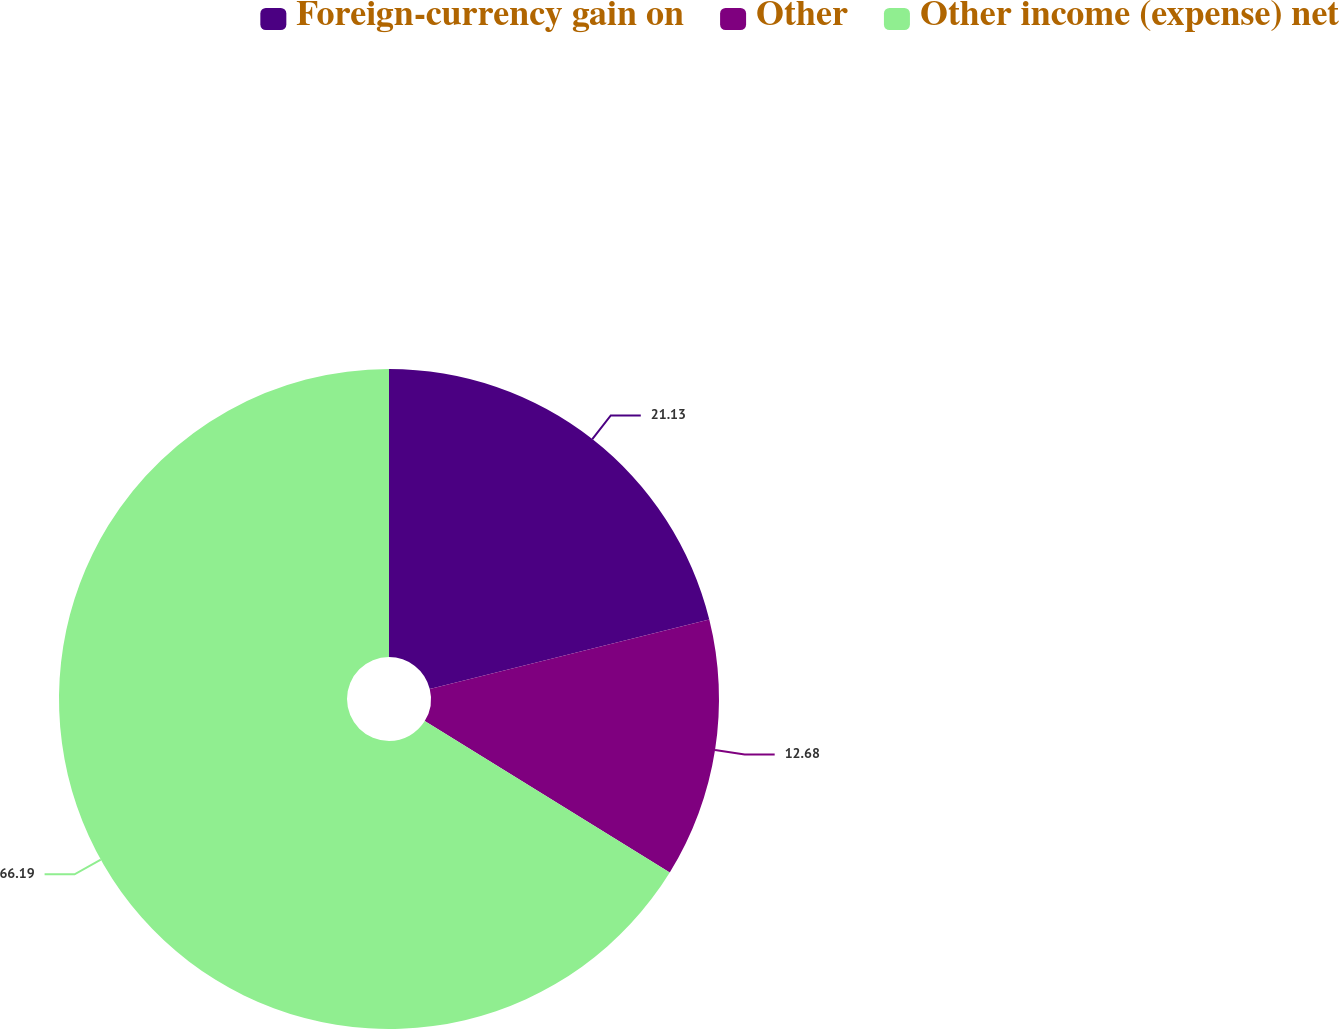Convert chart. <chart><loc_0><loc_0><loc_500><loc_500><pie_chart><fcel>Foreign-currency gain on<fcel>Other<fcel>Other income (expense) net<nl><fcel>21.13%<fcel>12.68%<fcel>66.2%<nl></chart> 